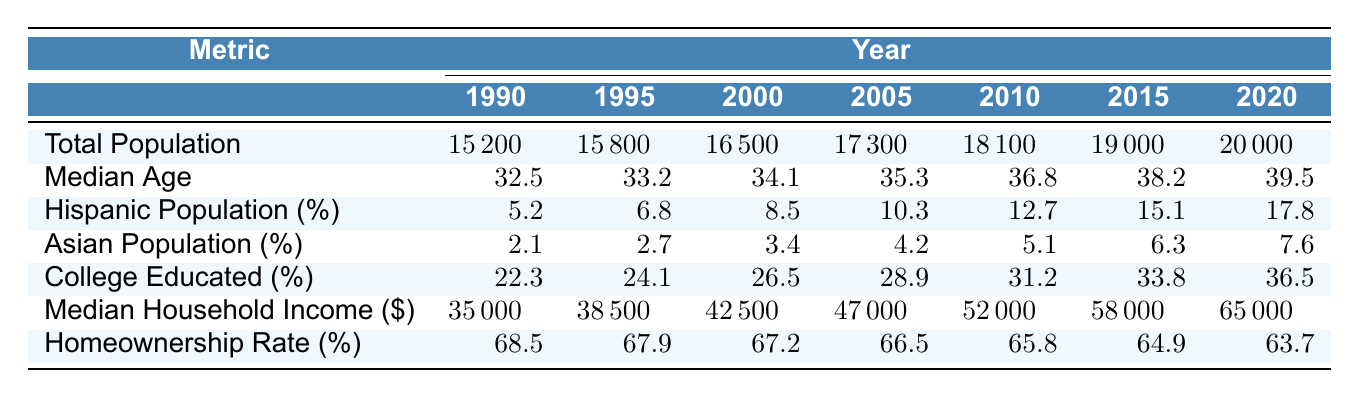What was the total population in 2000? In the table under the "Total Population" metric, the value for the year 2000 is listed as 16500.
Answer: 16500 What is the median age of the population in 2015? The median age for the year 2015 is explicitly stated in the table under the "Median Age" metric, which shows 38.2.
Answer: 38.2 How much did the median household income increase from 1990 to 2020? The median household income in 1990 was 35000 and in 2020 it was 65000. The increase is 65000 - 35000 = 30000.
Answer: 30000 Is the percentage of Hispanic population greater than 10% in 2005? In the table, the Hispanic population percentage for 2005 is 10.3%, which is greater than 10%. Therefore, the answer is yes.
Answer: Yes What is the change in the homeownership rate from 1990 to 2020? The homeownership rate in 1990 was 68.5% and in 2020 it was 63.7%. The change is 63.7% - 68.5% = -4.8%.
Answer: -4.8% What percentage of the population was college educated in 2010? Looking at the "College Educated (%)" metric in the table for the year 2010, it shows a value of 31.2%.
Answer: 31.2% What is the average median age from 1990 to 2020? To find the average median age, add up all ages: 32.5 + 33.2 + 34.1 + 35.3 + 36.8 + 38.2 + 39.5 = 309.6, then divide by 7 (the number of years), which is approximately 44.23.
Answer: 44.23 What was the total population change between 1990 and 2020? The total population in 1990 was 15200 and in 2020 it was 20000. The change is calculated as 20000 - 15200 = 4800.
Answer: 4800 How much has the Asian population percentage increased from 1990 to 2015? The percentage of the Asian population was 2.1% in 1990 and 6.3% in 2015. The increase is calculated as 6.3% - 2.1% = 4.2%.
Answer: 4.2% Were there more college-educated individuals in 2005 than there were in 2000? In 2000, the college-educated percentage was 26.5%, and in 2005 it increased to 28.9%. Since 28.9% > 26.5%, the answer is yes.
Answer: Yes 